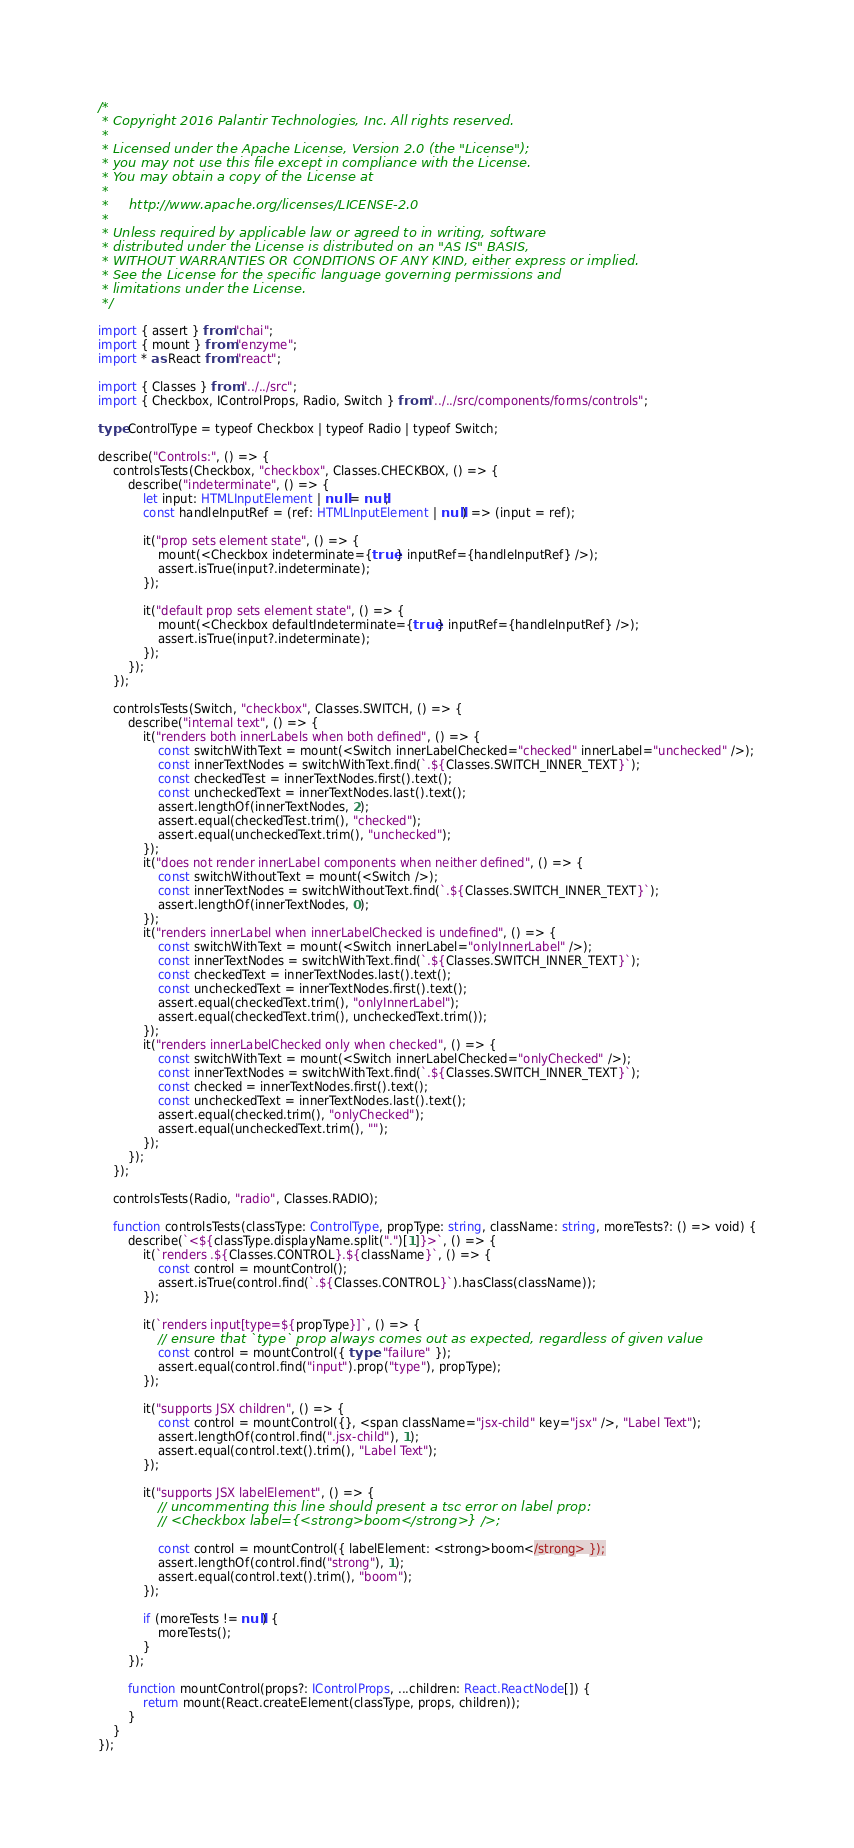Convert code to text. <code><loc_0><loc_0><loc_500><loc_500><_TypeScript_>/*
 * Copyright 2016 Palantir Technologies, Inc. All rights reserved.
 *
 * Licensed under the Apache License, Version 2.0 (the "License");
 * you may not use this file except in compliance with the License.
 * You may obtain a copy of the License at
 *
 *     http://www.apache.org/licenses/LICENSE-2.0
 *
 * Unless required by applicable law or agreed to in writing, software
 * distributed under the License is distributed on an "AS IS" BASIS,
 * WITHOUT WARRANTIES OR CONDITIONS OF ANY KIND, either express or implied.
 * See the License for the specific language governing permissions and
 * limitations under the License.
 */

import { assert } from "chai";
import { mount } from "enzyme";
import * as React from "react";

import { Classes } from "../../src";
import { Checkbox, IControlProps, Radio, Switch } from "../../src/components/forms/controls";

type ControlType = typeof Checkbox | typeof Radio | typeof Switch;

describe("Controls:", () => {
    controlsTests(Checkbox, "checkbox", Classes.CHECKBOX, () => {
        describe("indeterminate", () => {
            let input: HTMLInputElement | null = null;
            const handleInputRef = (ref: HTMLInputElement | null) => (input = ref);

            it("prop sets element state", () => {
                mount(<Checkbox indeterminate={true} inputRef={handleInputRef} />);
                assert.isTrue(input?.indeterminate);
            });

            it("default prop sets element state", () => {
                mount(<Checkbox defaultIndeterminate={true} inputRef={handleInputRef} />);
                assert.isTrue(input?.indeterminate);
            });
        });
    });

    controlsTests(Switch, "checkbox", Classes.SWITCH, () => {
        describe("internal text", () => {
            it("renders both innerLabels when both defined", () => {
                const switchWithText = mount(<Switch innerLabelChecked="checked" innerLabel="unchecked" />);
                const innerTextNodes = switchWithText.find(`.${Classes.SWITCH_INNER_TEXT}`);
                const checkedTest = innerTextNodes.first().text();
                const uncheckedText = innerTextNodes.last().text();
                assert.lengthOf(innerTextNodes, 2);
                assert.equal(checkedTest.trim(), "checked");
                assert.equal(uncheckedText.trim(), "unchecked");
            });
            it("does not render innerLabel components when neither defined", () => {
                const switchWithoutText = mount(<Switch />);
                const innerTextNodes = switchWithoutText.find(`.${Classes.SWITCH_INNER_TEXT}`);
                assert.lengthOf(innerTextNodes, 0);
            });
            it("renders innerLabel when innerLabelChecked is undefined", () => {
                const switchWithText = mount(<Switch innerLabel="onlyInnerLabel" />);
                const innerTextNodes = switchWithText.find(`.${Classes.SWITCH_INNER_TEXT}`);
                const checkedText = innerTextNodes.last().text();
                const uncheckedText = innerTextNodes.first().text();
                assert.equal(checkedText.trim(), "onlyInnerLabel");
                assert.equal(checkedText.trim(), uncheckedText.trim());
            });
            it("renders innerLabelChecked only when checked", () => {
                const switchWithText = mount(<Switch innerLabelChecked="onlyChecked" />);
                const innerTextNodes = switchWithText.find(`.${Classes.SWITCH_INNER_TEXT}`);
                const checked = innerTextNodes.first().text();
                const uncheckedText = innerTextNodes.last().text();
                assert.equal(checked.trim(), "onlyChecked");
                assert.equal(uncheckedText.trim(), "");
            });
        });
    });

    controlsTests(Radio, "radio", Classes.RADIO);

    function controlsTests(classType: ControlType, propType: string, className: string, moreTests?: () => void) {
        describe(`<${classType.displayName.split(".")[1]}>`, () => {
            it(`renders .${Classes.CONTROL}.${className}`, () => {
                const control = mountControl();
                assert.isTrue(control.find(`.${Classes.CONTROL}`).hasClass(className));
            });

            it(`renders input[type=${propType}]`, () => {
                // ensure that `type` prop always comes out as expected, regardless of given value
                const control = mountControl({ type: "failure" });
                assert.equal(control.find("input").prop("type"), propType);
            });

            it("supports JSX children", () => {
                const control = mountControl({}, <span className="jsx-child" key="jsx" />, "Label Text");
                assert.lengthOf(control.find(".jsx-child"), 1);
                assert.equal(control.text().trim(), "Label Text");
            });

            it("supports JSX labelElement", () => {
                // uncommenting this line should present a tsc error on label prop:
                // <Checkbox label={<strong>boom</strong>} />;

                const control = mountControl({ labelElement: <strong>boom</strong> });
                assert.lengthOf(control.find("strong"), 1);
                assert.equal(control.text().trim(), "boom");
            });

            if (moreTests != null) {
                moreTests();
            }
        });

        function mountControl(props?: IControlProps, ...children: React.ReactNode[]) {
            return mount(React.createElement(classType, props, children));
        }
    }
});
</code> 